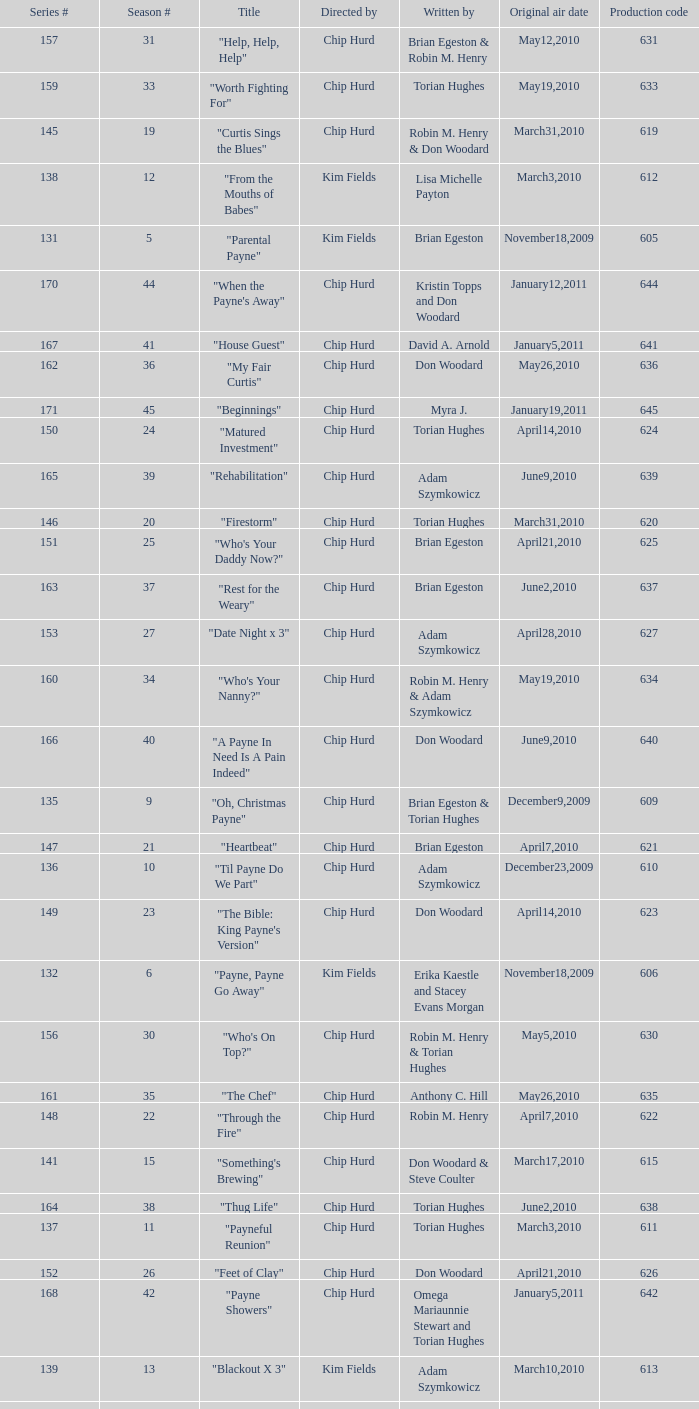What is the original air dates for the title "firestorm"? March31,2010. 